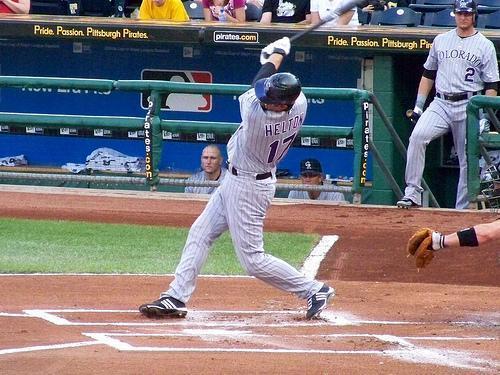How many people are batting?
Give a very brief answer. 1. 